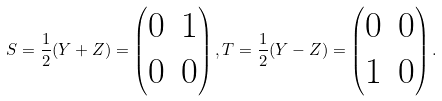Convert formula to latex. <formula><loc_0><loc_0><loc_500><loc_500>S = { \frac { 1 } { 2 } } ( Y + Z ) = \begin{pmatrix} 0 & 1 \\ 0 & 0 \end{pmatrix} , T = { \frac { 1 } { 2 } } ( Y - Z ) = \begin{pmatrix} 0 & 0 \\ 1 & 0 \end{pmatrix} .</formula> 